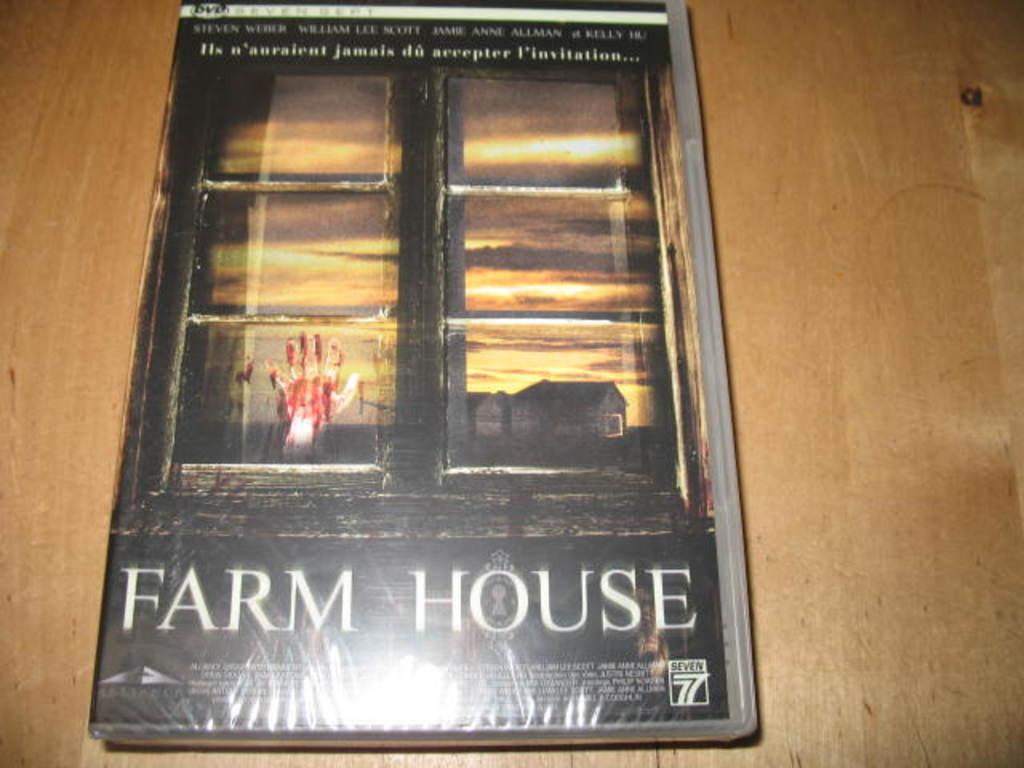<image>
Summarize the visual content of the image. A book called Farm House on a wooden table. 